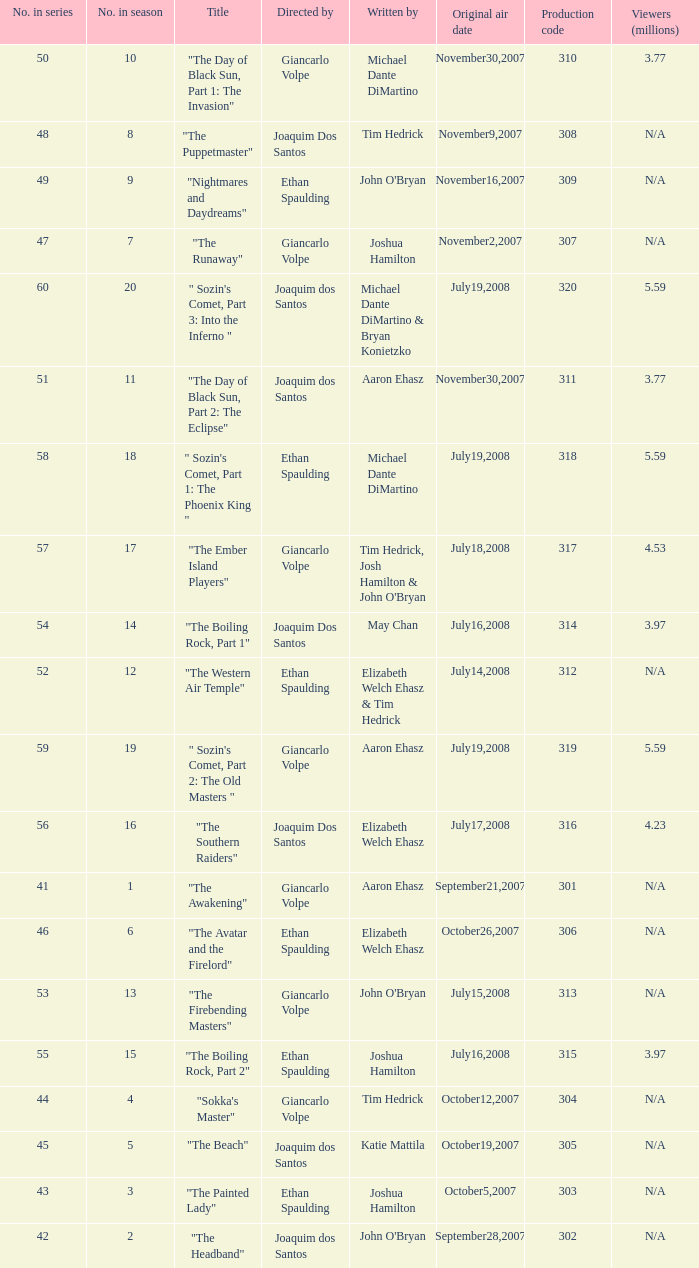What season has an episode written by john o'bryan and directed by ethan spaulding? 9.0. 